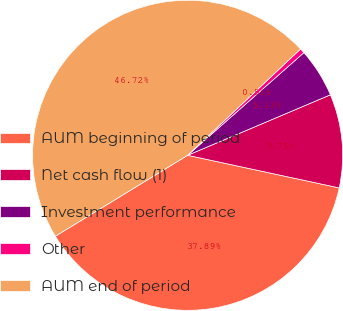<chart> <loc_0><loc_0><loc_500><loc_500><pie_chart><fcel>AUM beginning of period<fcel>Net cash flow (1)<fcel>Investment performance<fcel>Other<fcel>AUM end of period<nl><fcel>37.88%<fcel>9.75%<fcel>5.13%<fcel>0.51%<fcel>46.71%<nl></chart> 